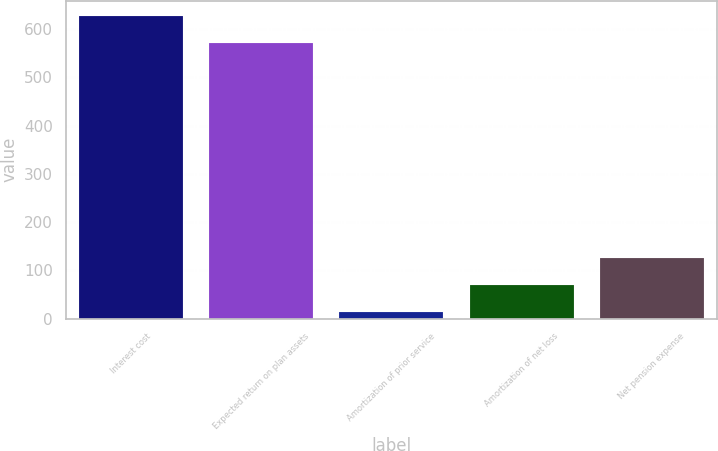Convert chart to OTSL. <chart><loc_0><loc_0><loc_500><loc_500><bar_chart><fcel>Interest cost<fcel>Expected return on plan assets<fcel>Amortization of prior service<fcel>Amortization of net loss<fcel>Net pension expense<nl><fcel>627.2<fcel>571<fcel>14<fcel>70.2<fcel>126.4<nl></chart> 